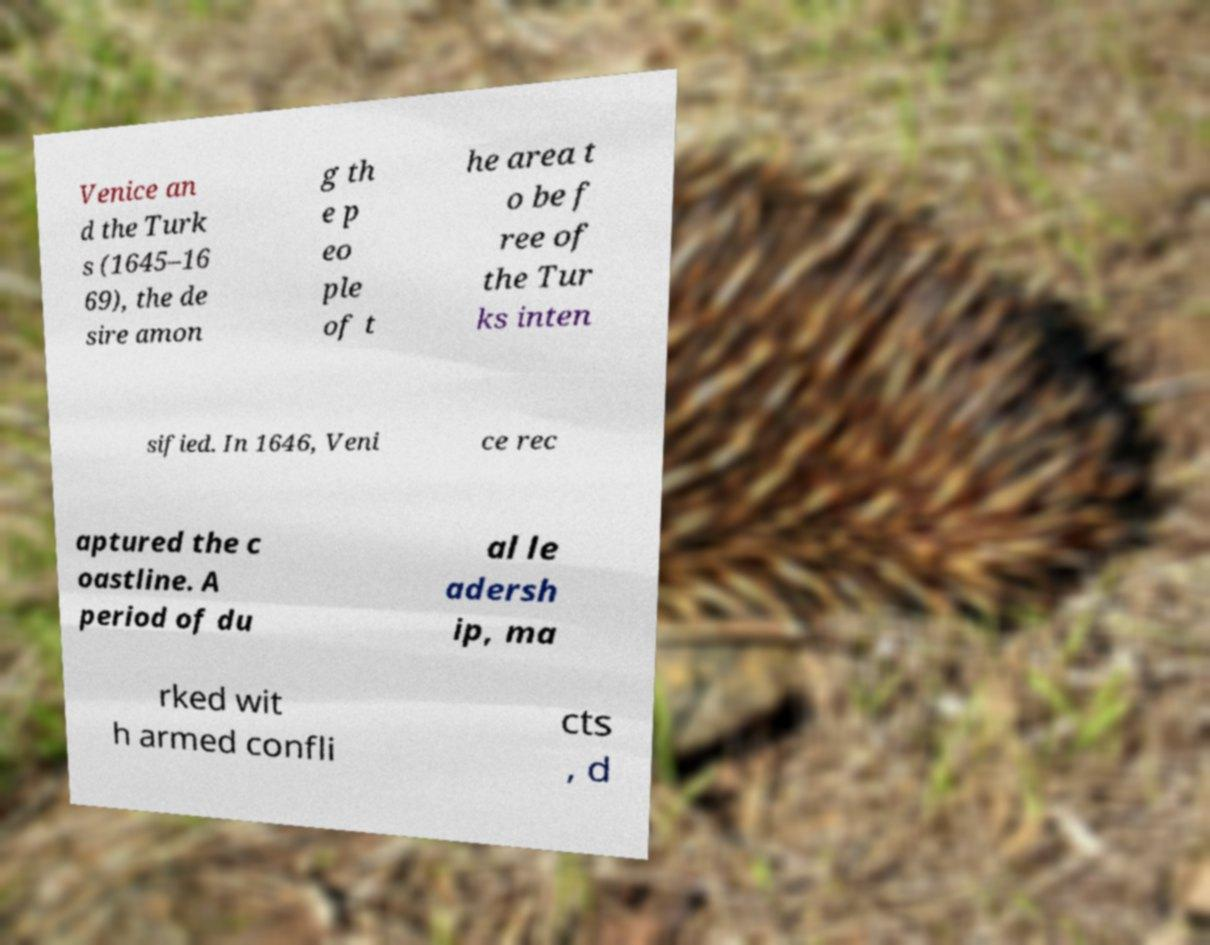Can you accurately transcribe the text from the provided image for me? Venice an d the Turk s (1645–16 69), the de sire amon g th e p eo ple of t he area t o be f ree of the Tur ks inten sified. In 1646, Veni ce rec aptured the c oastline. A period of du al le adersh ip, ma rked wit h armed confli cts , d 